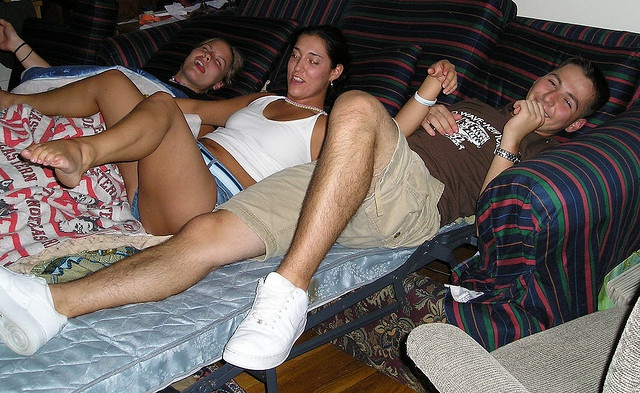Describe the objects in this image and their specific colors. I can see bed in black, darkgray, maroon, and gray tones, couch in black, maroon, and gray tones, people in black, white, tan, gray, and darkgray tones, people in black, gray, brown, and lightgray tones, and chair in black, darkgray, gray, and lightgray tones in this image. 